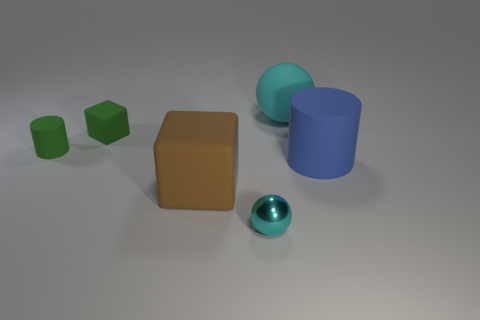What number of other things are the same shape as the brown matte object?
Give a very brief answer. 1. What number of blue objects are either big spheres or cylinders?
Offer a terse response. 1. Is the shape of the small metal thing the same as the blue matte object?
Your response must be concise. No. Is there a small block right of the cyan thing that is behind the tiny sphere?
Keep it short and to the point. No. Is the number of cyan spheres behind the cyan metal thing the same as the number of small blue cylinders?
Your response must be concise. No. What number of other objects are the same size as the green matte cube?
Provide a short and direct response. 2. Does the cylinder right of the tiny cyan thing have the same material as the cyan sphere that is right of the shiny object?
Provide a short and direct response. Yes. What size is the cyan ball that is behind the rubber cylinder that is on the right side of the green rubber block?
Your answer should be very brief. Large. Are there any things of the same color as the small rubber cylinder?
Your response must be concise. Yes. There is a big object that is on the right side of the large cyan rubber object; does it have the same color as the sphere that is in front of the green cube?
Your answer should be compact. No. 